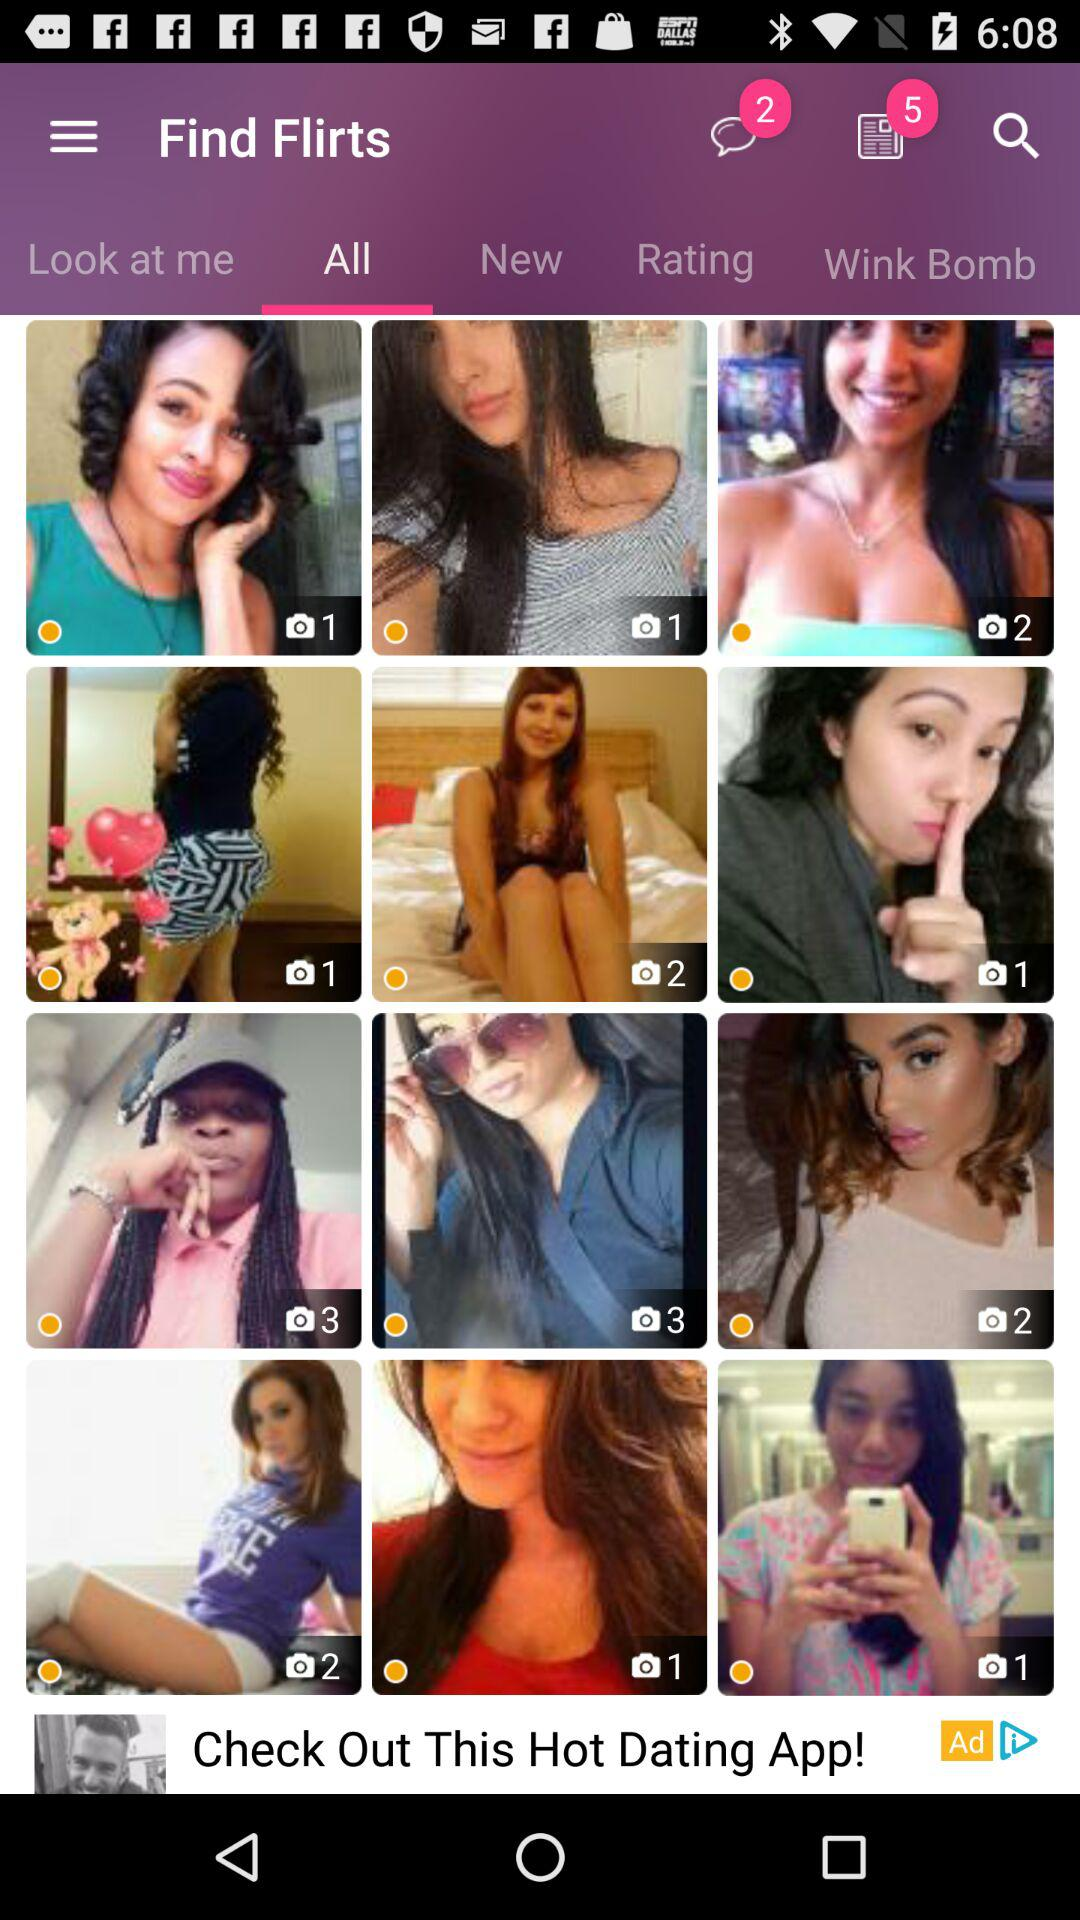Which tab is selected? The selected tab is "All". 